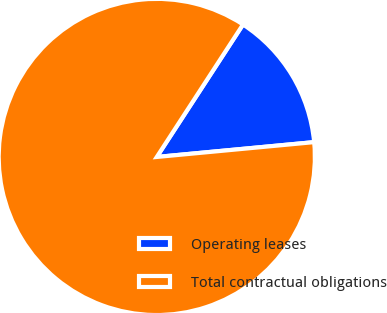Convert chart. <chart><loc_0><loc_0><loc_500><loc_500><pie_chart><fcel>Operating leases<fcel>Total contractual obligations<nl><fcel>14.32%<fcel>85.68%<nl></chart> 